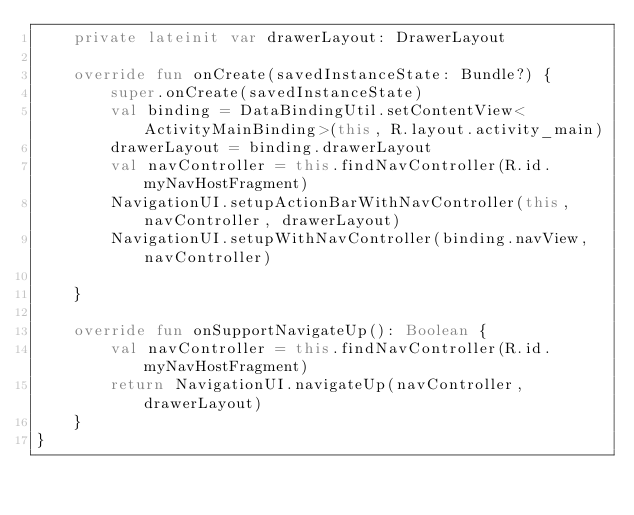<code> <loc_0><loc_0><loc_500><loc_500><_Kotlin_>    private lateinit var drawerLayout: DrawerLayout

    override fun onCreate(savedInstanceState: Bundle?) {
        super.onCreate(savedInstanceState)
        val binding = DataBindingUtil.setContentView<ActivityMainBinding>(this, R.layout.activity_main)
        drawerLayout = binding.drawerLayout
        val navController = this.findNavController(R.id.myNavHostFragment)
        NavigationUI.setupActionBarWithNavController(this,navController, drawerLayout)
        NavigationUI.setupWithNavController(binding.navView, navController)

    }

    override fun onSupportNavigateUp(): Boolean {
        val navController = this.findNavController(R.id.myNavHostFragment)
        return NavigationUI.navigateUp(navController, drawerLayout)
    }
}
</code> 